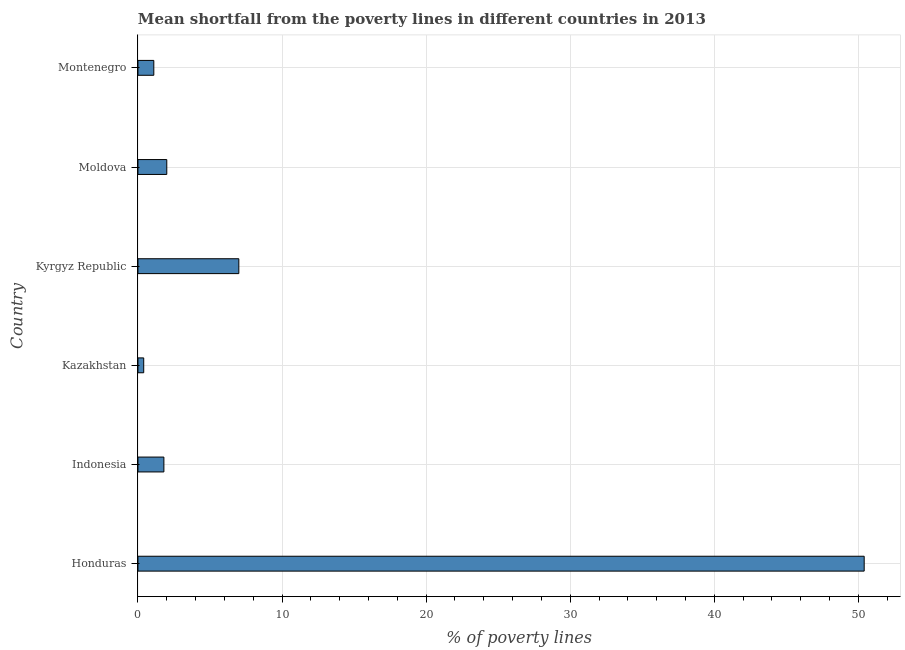What is the title of the graph?
Your response must be concise. Mean shortfall from the poverty lines in different countries in 2013. What is the label or title of the X-axis?
Your answer should be compact. % of poverty lines. What is the label or title of the Y-axis?
Make the answer very short. Country. What is the poverty gap at national poverty lines in Kyrgyz Republic?
Ensure brevity in your answer.  7. Across all countries, what is the maximum poverty gap at national poverty lines?
Provide a short and direct response. 50.4. Across all countries, what is the minimum poverty gap at national poverty lines?
Your answer should be very brief. 0.4. In which country was the poverty gap at national poverty lines maximum?
Give a very brief answer. Honduras. In which country was the poverty gap at national poverty lines minimum?
Your response must be concise. Kazakhstan. What is the sum of the poverty gap at national poverty lines?
Ensure brevity in your answer.  62.7. What is the difference between the poverty gap at national poverty lines in Honduras and Kyrgyz Republic?
Your answer should be compact. 43.4. What is the average poverty gap at national poverty lines per country?
Make the answer very short. 10.45. In how many countries, is the poverty gap at national poverty lines greater than 44 %?
Your answer should be compact. 1. What is the ratio of the poverty gap at national poverty lines in Honduras to that in Kazakhstan?
Your response must be concise. 126. What is the difference between the highest and the second highest poverty gap at national poverty lines?
Make the answer very short. 43.4. Is the sum of the poverty gap at national poverty lines in Indonesia and Moldova greater than the maximum poverty gap at national poverty lines across all countries?
Provide a short and direct response. No. What is the difference between the highest and the lowest poverty gap at national poverty lines?
Offer a terse response. 50. How many bars are there?
Your answer should be very brief. 6. What is the difference between two consecutive major ticks on the X-axis?
Offer a very short reply. 10. What is the % of poverty lines in Honduras?
Ensure brevity in your answer.  50.4. What is the % of poverty lines of Indonesia?
Offer a very short reply. 1.8. What is the % of poverty lines of Kazakhstan?
Ensure brevity in your answer.  0.4. What is the % of poverty lines in Kyrgyz Republic?
Provide a short and direct response. 7. What is the difference between the % of poverty lines in Honduras and Indonesia?
Your response must be concise. 48.6. What is the difference between the % of poverty lines in Honduras and Kyrgyz Republic?
Give a very brief answer. 43.4. What is the difference between the % of poverty lines in Honduras and Moldova?
Provide a succinct answer. 48.4. What is the difference between the % of poverty lines in Honduras and Montenegro?
Provide a short and direct response. 49.3. What is the difference between the % of poverty lines in Indonesia and Moldova?
Give a very brief answer. -0.2. What is the difference between the % of poverty lines in Indonesia and Montenegro?
Your response must be concise. 0.7. What is the difference between the % of poverty lines in Kazakhstan and Kyrgyz Republic?
Ensure brevity in your answer.  -6.6. What is the difference between the % of poverty lines in Kazakhstan and Montenegro?
Offer a terse response. -0.7. What is the difference between the % of poverty lines in Kyrgyz Republic and Moldova?
Your answer should be very brief. 5. What is the ratio of the % of poverty lines in Honduras to that in Indonesia?
Offer a very short reply. 28. What is the ratio of the % of poverty lines in Honduras to that in Kazakhstan?
Offer a very short reply. 126. What is the ratio of the % of poverty lines in Honduras to that in Moldova?
Your answer should be very brief. 25.2. What is the ratio of the % of poverty lines in Honduras to that in Montenegro?
Offer a very short reply. 45.82. What is the ratio of the % of poverty lines in Indonesia to that in Kyrgyz Republic?
Keep it short and to the point. 0.26. What is the ratio of the % of poverty lines in Indonesia to that in Montenegro?
Keep it short and to the point. 1.64. What is the ratio of the % of poverty lines in Kazakhstan to that in Kyrgyz Republic?
Make the answer very short. 0.06. What is the ratio of the % of poverty lines in Kazakhstan to that in Montenegro?
Offer a very short reply. 0.36. What is the ratio of the % of poverty lines in Kyrgyz Republic to that in Moldova?
Provide a short and direct response. 3.5. What is the ratio of the % of poverty lines in Kyrgyz Republic to that in Montenegro?
Your answer should be very brief. 6.36. What is the ratio of the % of poverty lines in Moldova to that in Montenegro?
Your response must be concise. 1.82. 